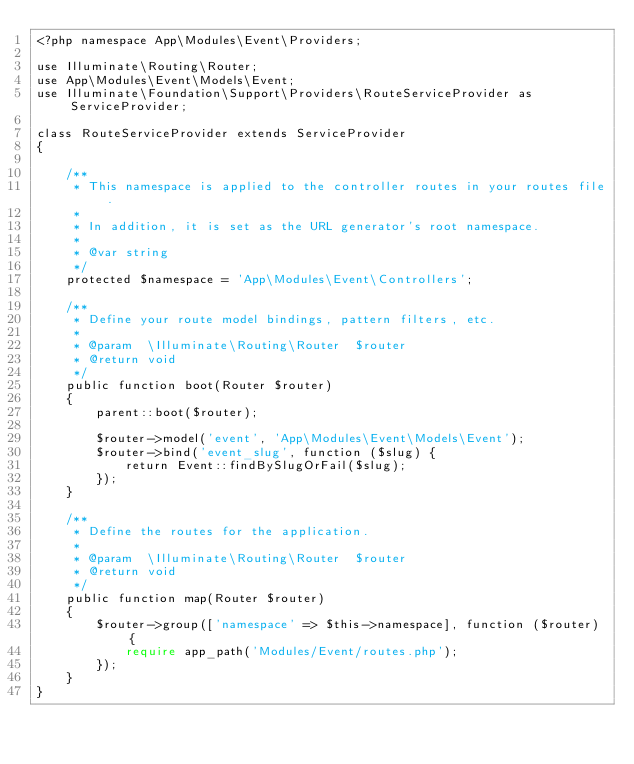<code> <loc_0><loc_0><loc_500><loc_500><_PHP_><?php namespace App\Modules\Event\Providers;

use Illuminate\Routing\Router;
use App\Modules\Event\Models\Event;
use Illuminate\Foundation\Support\Providers\RouteServiceProvider as ServiceProvider;

class RouteServiceProvider extends ServiceProvider
{

    /**
     * This namespace is applied to the controller routes in your routes file.
     *
     * In addition, it is set as the URL generator's root namespace.
     *
     * @var string
     */
    protected $namespace = 'App\Modules\Event\Controllers';

    /**
     * Define your route model bindings, pattern filters, etc.
     *
     * @param  \Illuminate\Routing\Router  $router
     * @return void
     */
    public function boot(Router $router)
    {
        parent::boot($router);

        $router->model('event', 'App\Modules\Event\Models\Event');
        $router->bind('event_slug', function ($slug) {
            return Event::findBySlugOrFail($slug);
        });
    }

    /**
     * Define the routes for the application.
     *
     * @param  \Illuminate\Routing\Router  $router
     * @return void
     */
    public function map(Router $router)
    {
        $router->group(['namespace' => $this->namespace], function ($router) {
            require app_path('Modules/Event/routes.php');
        });
    }
}
</code> 